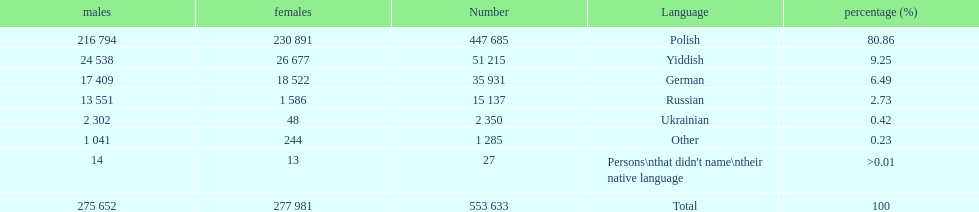Which language did the most people in the imperial census of 1897 speak in the p&#322;ock governorate? Polish. Could you parse the entire table as a dict? {'header': ['males', 'females', 'Number', 'Language', 'percentage (%)'], 'rows': [['216 794', '230 891', '447 685', 'Polish', '80.86'], ['24 538', '26 677', '51 215', 'Yiddish', '9.25'], ['17 409', '18 522', '35 931', 'German', '6.49'], ['13 551', '1 586', '15 137', 'Russian', '2.73'], ['2 302', '48', '2 350', 'Ukrainian', '0.42'], ['1 041', '244', '1 285', 'Other', '0.23'], ['14', '13', '27', "Persons\\nthat didn't name\\ntheir native language", '>0.01'], ['275 652', '277 981', '553 633', 'Total', '100']]} 